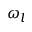Convert formula to latex. <formula><loc_0><loc_0><loc_500><loc_500>\omega _ { l }</formula> 